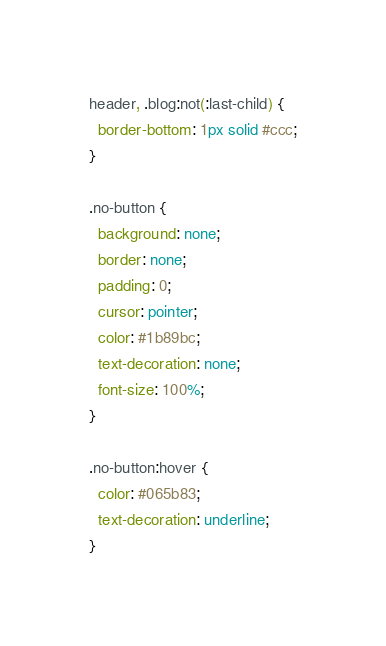<code> <loc_0><loc_0><loc_500><loc_500><_CSS_>header, .blog:not(:last-child) {
  border-bottom: 1px solid #ccc;
}

.no-button {
  background: none;
  border: none;
  padding: 0;
  cursor: pointer;
  color: #1b89bc;
  text-decoration: none;
  font-size: 100%;
}

.no-button:hover {
  color: #065b83;
  text-decoration: underline;
}

</code> 